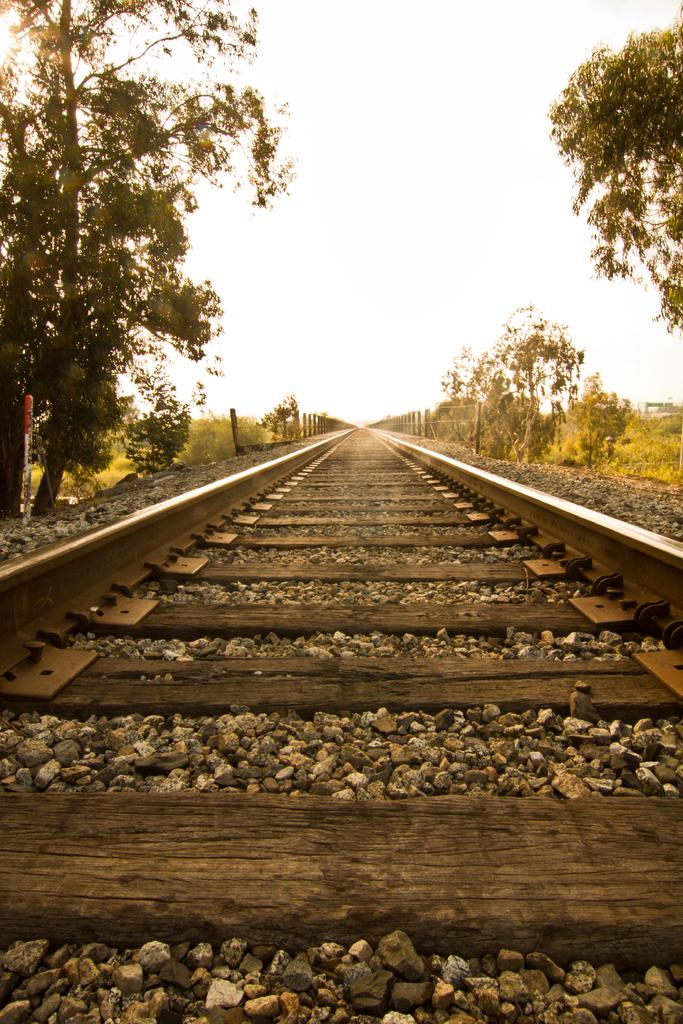What type of transportation infrastructure is visible in the image? There is a railway track in the image. What can be seen on the path alongside the railway track? Stones and wooden items are visible on the path. What is present on both sides of the railway track? Trees and poles are present on both sides of the railway track. What is visible in the background of the image? The sky is visible in the image. What type of gold ornament is hanging from the trees on the left side of the track? There is no gold ornament present in the image; only trees and poles are visible on both sides of the railway track. 